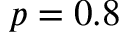Convert formula to latex. <formula><loc_0><loc_0><loc_500><loc_500>p = 0 . 8</formula> 